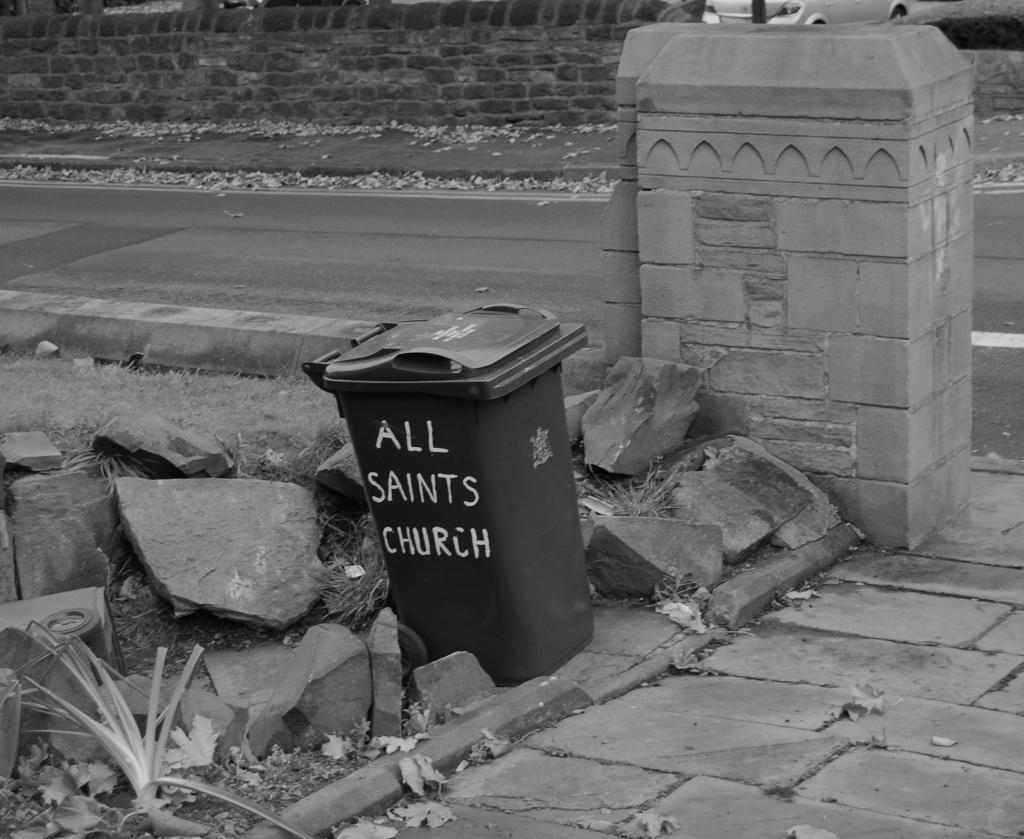<image>
Share a concise interpretation of the image provided. A garbage can sits on a curb from All Saints Church 